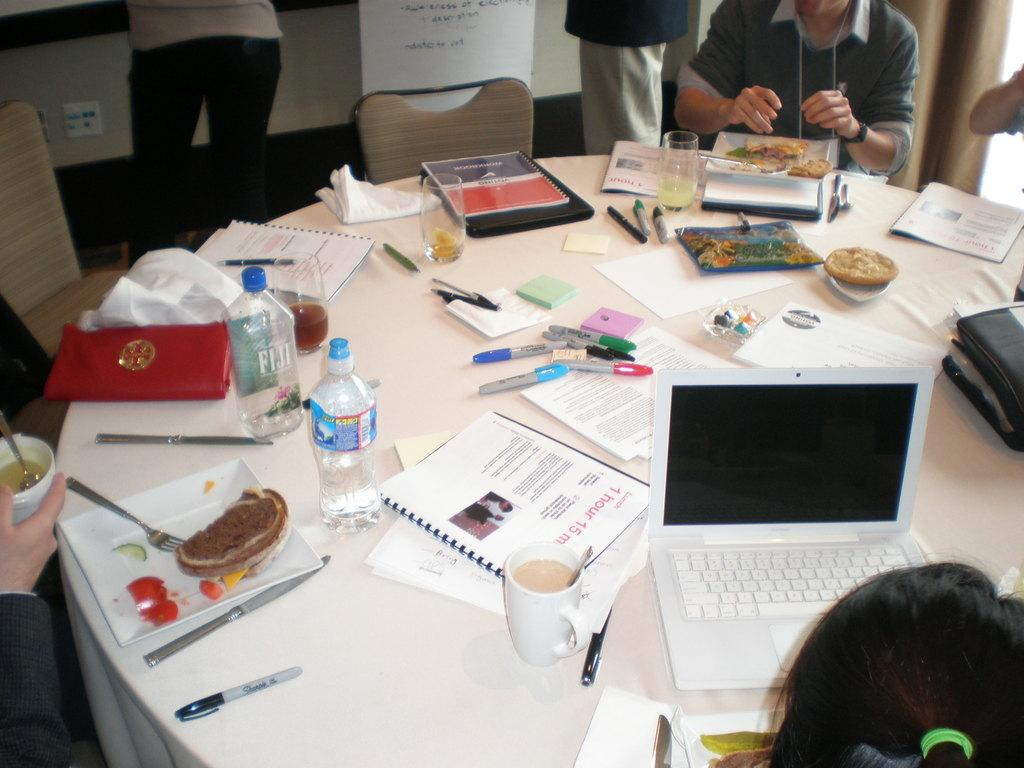What are the people in the image doing? There are persons sitting on chairs and standing in the image. What can be seen on the table in the image? There is a laptop, a plate, a pen, a bottle, a glass, a paper, and a book on the table. How many items are on the table in the image? There are eight items on the table in the image. What color are the eyes of the stone in the image? There is no stone or eyes present in the image. 